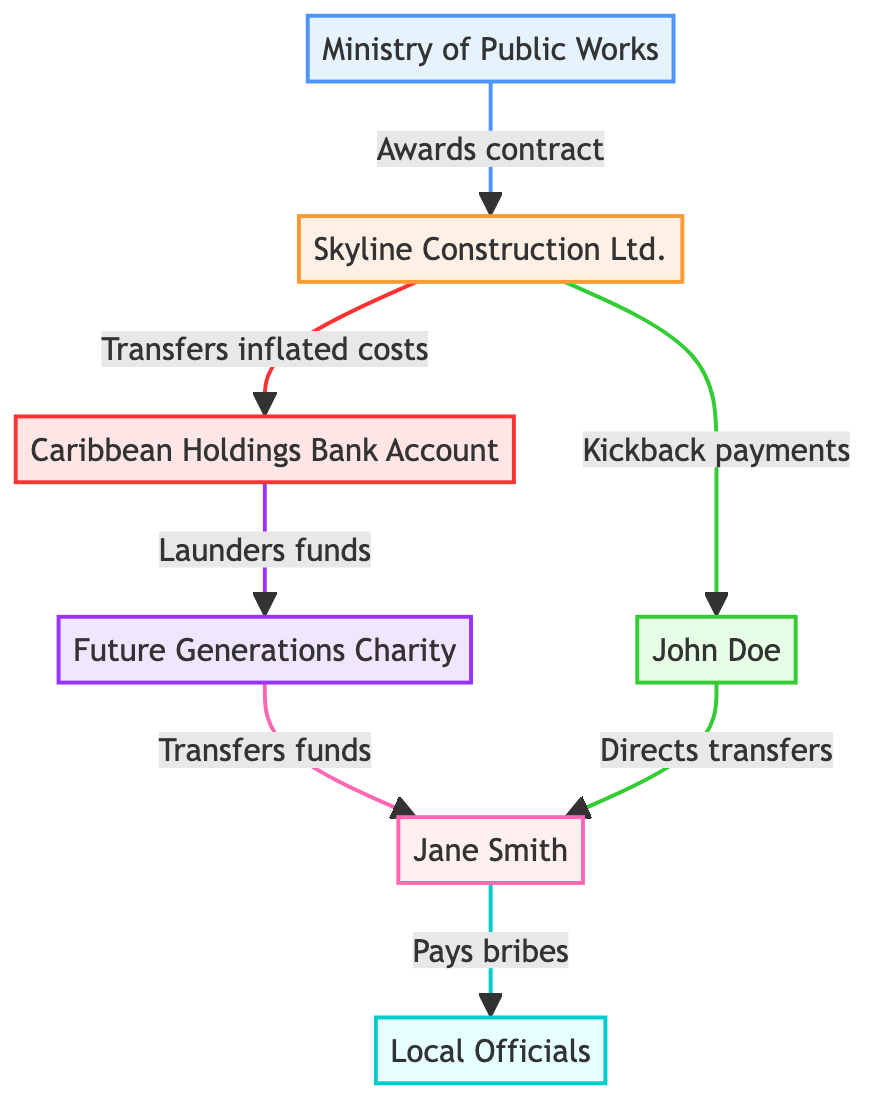What type of entity is Skyline Construction Ltd.? Skyline Construction Ltd. is classified as a Private Company in the diagram. This is identified by examining the node labeled "Skyline Construction Ltd." and acknowledging its type within the provided data.
Answer: Private Company How many key entities are involved in the asset diversion chain? The diagram details a total of seven key entities, as indicated by the seven distinct nodes present: Ministry of Public Works, Skyline Construction Ltd., John Doe, Caribbean Holdings Bank Account, Future Generations Charity, Jane Smith, and Local Officials.
Answer: Seven What relationship exists between the Ministry of Public Works and Skyline Construction Ltd.? The relationship defined between the Ministry of Public Works and Skyline Construction Ltd. is labeled as "awarded contract." This is visible in the directed arrow connecting these two nodes within the diagram.
Answer: Awarded contract Who is responsible for transferring funds between entities? The entity responsible for transferring funds is Jane Smith, indicated in the diagram as the Business Associate with a connection flowing from the NGO towards Local Officials.
Answer: Jane Smith What type of relationship connects Skyline Construction Ltd. to the Offshore Account? The type of relationship that connects Skyline Construction Ltd. to the Offshore Account is depicted as "fund transfer," based on the arrow linking these two nodes and the corresponding label explaining the interaction.
Answer: Fund transfer Which entity receives kickback payments? The entity that receives kickback payments is John Doe, as indicated by the connection where Skyline Construction Ltd. funnels financial benefits to him through the labeled relationship of “kickback.”
Answer: John Doe What is the ultimate purpose of the funds transferred to the NGO? The ultimate purpose of the funds transferred to the NGO is for money laundering, as denoted by the relationship labeled "laundered funds" flowing from the Offshore Account to the NGO.
Answer: Money laundering What is the role of local officials in this network? Local officials play the role of "Kickback Receiver," which means they are involved in accepting bribes to facilitate the smooth operations of the diversion scheme as illustrated by the connection from Jane Smith.
Answer: Kickback Receiver 